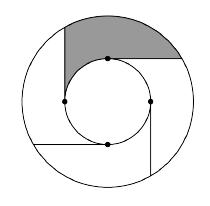Let $T$ be $7$. The diagram below features two concentric circles of radius $1$ and $T$ (not necessarily to scale). Four equally spaced points are chosen on the smaller circle, and rays are drawn from these points to the larger circle such that all of the rays are tangent to the smaller circle and no two rays intersect. If the area of the shaded region can be expressed as $k\pi$ for some integer $k$, find $k$. The solution involves calculating the area of the shaded region formed between two concentric circles with radii $1$ and $7$, disrupted by four tangent lines from the smaller circle creating sectors. To find the area of the shaded sector, we first determine the areas of the larger and smaller circles, respectively. The area of the larger circle is $49\pi$, while the area of the smaller circle is $\pi$. Subtracting these gives $48\pi$. Four equally spaced points result in the region outside the smaller circle but within the larger, divided into four equal segments. As these tangent lines do not overlap inside the larger circle, each segment has equal area, and some segments are shaded. Calculating the proportion of shaded segments, given the geometry and how they are shaded alternatingly, the shaded area is $12\pi$ — a nuanced question, but the calculation provides a direct insight into solving problems involving areas of concentric circles and intersecting chords or tangents. 